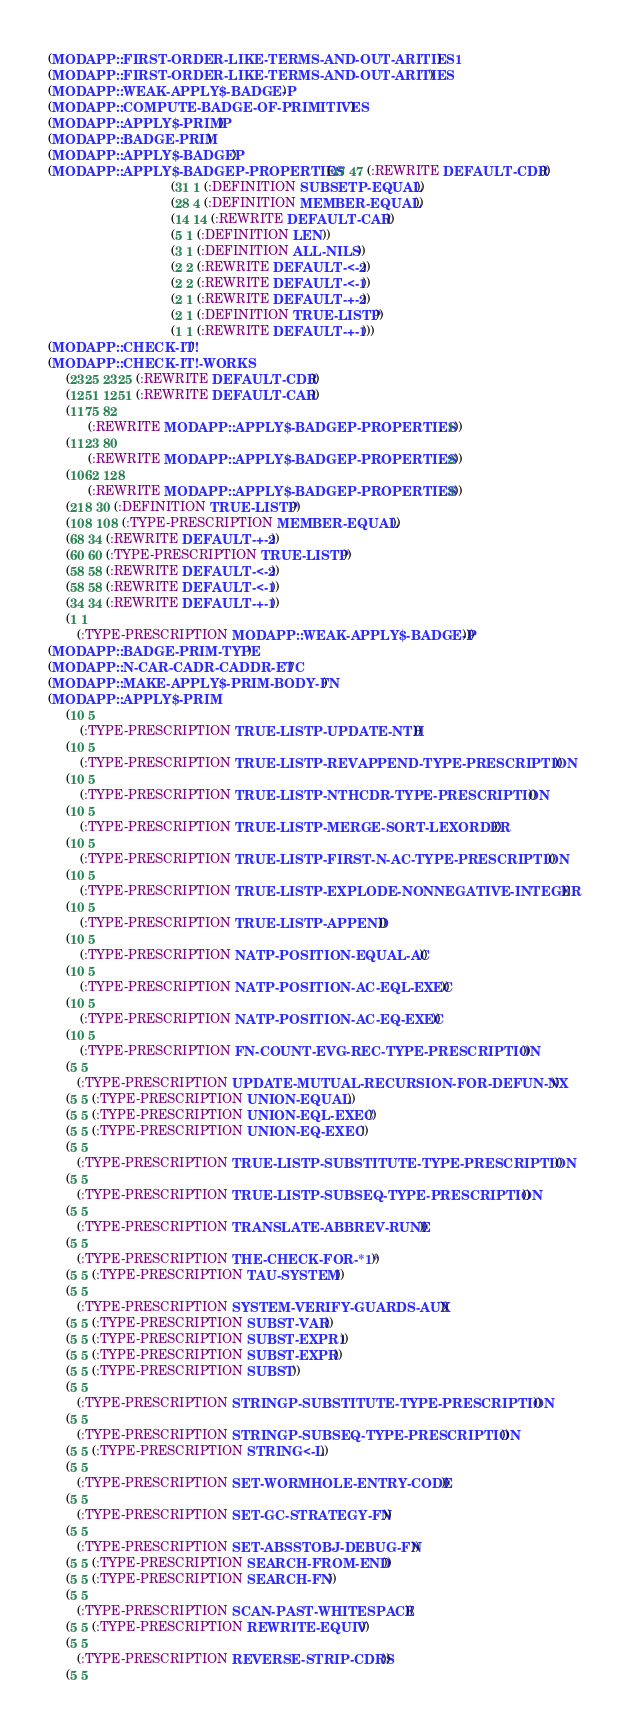Convert code to text. <code><loc_0><loc_0><loc_500><loc_500><_Lisp_>(MODAPP::FIRST-ORDER-LIKE-TERMS-AND-OUT-ARITIES1)
(MODAPP::FIRST-ORDER-LIKE-TERMS-AND-OUT-ARITIES)
(MODAPP::WEAK-APPLY$-BADGE-P)
(MODAPP::COMPUTE-BADGE-OF-PRIMITIVES)
(MODAPP::APPLY$-PRIMP)
(MODAPP::BADGE-PRIM)
(MODAPP::APPLY$-BADGEP)
(MODAPP::APPLY$-BADGEP-PROPERTIES (47 47 (:REWRITE DEFAULT-CDR))
                                  (31 1 (:DEFINITION SUBSETP-EQUAL))
                                  (28 4 (:DEFINITION MEMBER-EQUAL))
                                  (14 14 (:REWRITE DEFAULT-CAR))
                                  (5 1 (:DEFINITION LEN))
                                  (3 1 (:DEFINITION ALL-NILS))
                                  (2 2 (:REWRITE DEFAULT-<-2))
                                  (2 2 (:REWRITE DEFAULT-<-1))
                                  (2 1 (:REWRITE DEFAULT-+-2))
                                  (2 1 (:DEFINITION TRUE-LISTP))
                                  (1 1 (:REWRITE DEFAULT-+-1)))
(MODAPP::CHECK-IT!)
(MODAPP::CHECK-IT!-WORKS
     (2325 2325 (:REWRITE DEFAULT-CDR))
     (1251 1251 (:REWRITE DEFAULT-CAR))
     (1175 82
           (:REWRITE MODAPP::APPLY$-BADGEP-PROPERTIES . 1))
     (1123 80
           (:REWRITE MODAPP::APPLY$-BADGEP-PROPERTIES . 2))
     (1062 128
           (:REWRITE MODAPP::APPLY$-BADGEP-PROPERTIES . 3))
     (218 30 (:DEFINITION TRUE-LISTP))
     (108 108 (:TYPE-PRESCRIPTION MEMBER-EQUAL))
     (68 34 (:REWRITE DEFAULT-+-2))
     (60 60 (:TYPE-PRESCRIPTION TRUE-LISTP))
     (58 58 (:REWRITE DEFAULT-<-2))
     (58 58 (:REWRITE DEFAULT-<-1))
     (34 34 (:REWRITE DEFAULT-+-1))
     (1 1
        (:TYPE-PRESCRIPTION MODAPP::WEAK-APPLY$-BADGE-P)))
(MODAPP::BADGE-PRIM-TYPE)
(MODAPP::N-CAR-CADR-CADDR-ETC)
(MODAPP::MAKE-APPLY$-PRIM-BODY-FN)
(MODAPP::APPLY$-PRIM
     (10 5
         (:TYPE-PRESCRIPTION TRUE-LISTP-UPDATE-NTH))
     (10 5
         (:TYPE-PRESCRIPTION TRUE-LISTP-REVAPPEND-TYPE-PRESCRIPTION))
     (10 5
         (:TYPE-PRESCRIPTION TRUE-LISTP-NTHCDR-TYPE-PRESCRIPTION))
     (10 5
         (:TYPE-PRESCRIPTION TRUE-LISTP-MERGE-SORT-LEXORDER))
     (10 5
         (:TYPE-PRESCRIPTION TRUE-LISTP-FIRST-N-AC-TYPE-PRESCRIPTION))
     (10 5
         (:TYPE-PRESCRIPTION TRUE-LISTP-EXPLODE-NONNEGATIVE-INTEGER))
     (10 5
         (:TYPE-PRESCRIPTION TRUE-LISTP-APPEND))
     (10 5
         (:TYPE-PRESCRIPTION NATP-POSITION-EQUAL-AC))
     (10 5
         (:TYPE-PRESCRIPTION NATP-POSITION-AC-EQL-EXEC))
     (10 5
         (:TYPE-PRESCRIPTION NATP-POSITION-AC-EQ-EXEC))
     (10 5
         (:TYPE-PRESCRIPTION FN-COUNT-EVG-REC-TYPE-PRESCRIPTION))
     (5 5
        (:TYPE-PRESCRIPTION UPDATE-MUTUAL-RECURSION-FOR-DEFUN-NX))
     (5 5 (:TYPE-PRESCRIPTION UNION-EQUAL))
     (5 5 (:TYPE-PRESCRIPTION UNION-EQL-EXEC))
     (5 5 (:TYPE-PRESCRIPTION UNION-EQ-EXEC))
     (5 5
        (:TYPE-PRESCRIPTION TRUE-LISTP-SUBSTITUTE-TYPE-PRESCRIPTION))
     (5 5
        (:TYPE-PRESCRIPTION TRUE-LISTP-SUBSEQ-TYPE-PRESCRIPTION))
     (5 5
        (:TYPE-PRESCRIPTION TRANSLATE-ABBREV-RUNE))
     (5 5
        (:TYPE-PRESCRIPTION THE-CHECK-FOR-*1*))
     (5 5 (:TYPE-PRESCRIPTION TAU-SYSTEM))
     (5 5
        (:TYPE-PRESCRIPTION SYSTEM-VERIFY-GUARDS-AUX))
     (5 5 (:TYPE-PRESCRIPTION SUBST-VAR))
     (5 5 (:TYPE-PRESCRIPTION SUBST-EXPR1))
     (5 5 (:TYPE-PRESCRIPTION SUBST-EXPR))
     (5 5 (:TYPE-PRESCRIPTION SUBST))
     (5 5
        (:TYPE-PRESCRIPTION STRINGP-SUBSTITUTE-TYPE-PRESCRIPTION))
     (5 5
        (:TYPE-PRESCRIPTION STRINGP-SUBSEQ-TYPE-PRESCRIPTION))
     (5 5 (:TYPE-PRESCRIPTION STRING<-L))
     (5 5
        (:TYPE-PRESCRIPTION SET-WORMHOLE-ENTRY-CODE))
     (5 5
        (:TYPE-PRESCRIPTION SET-GC-STRATEGY-FN))
     (5 5
        (:TYPE-PRESCRIPTION SET-ABSSTOBJ-DEBUG-FN))
     (5 5 (:TYPE-PRESCRIPTION SEARCH-FROM-END))
     (5 5 (:TYPE-PRESCRIPTION SEARCH-FN))
     (5 5
        (:TYPE-PRESCRIPTION SCAN-PAST-WHITESPACE))
     (5 5 (:TYPE-PRESCRIPTION REWRITE-EQUIV))
     (5 5
        (:TYPE-PRESCRIPTION REVERSE-STRIP-CDRS))
     (5 5</code> 